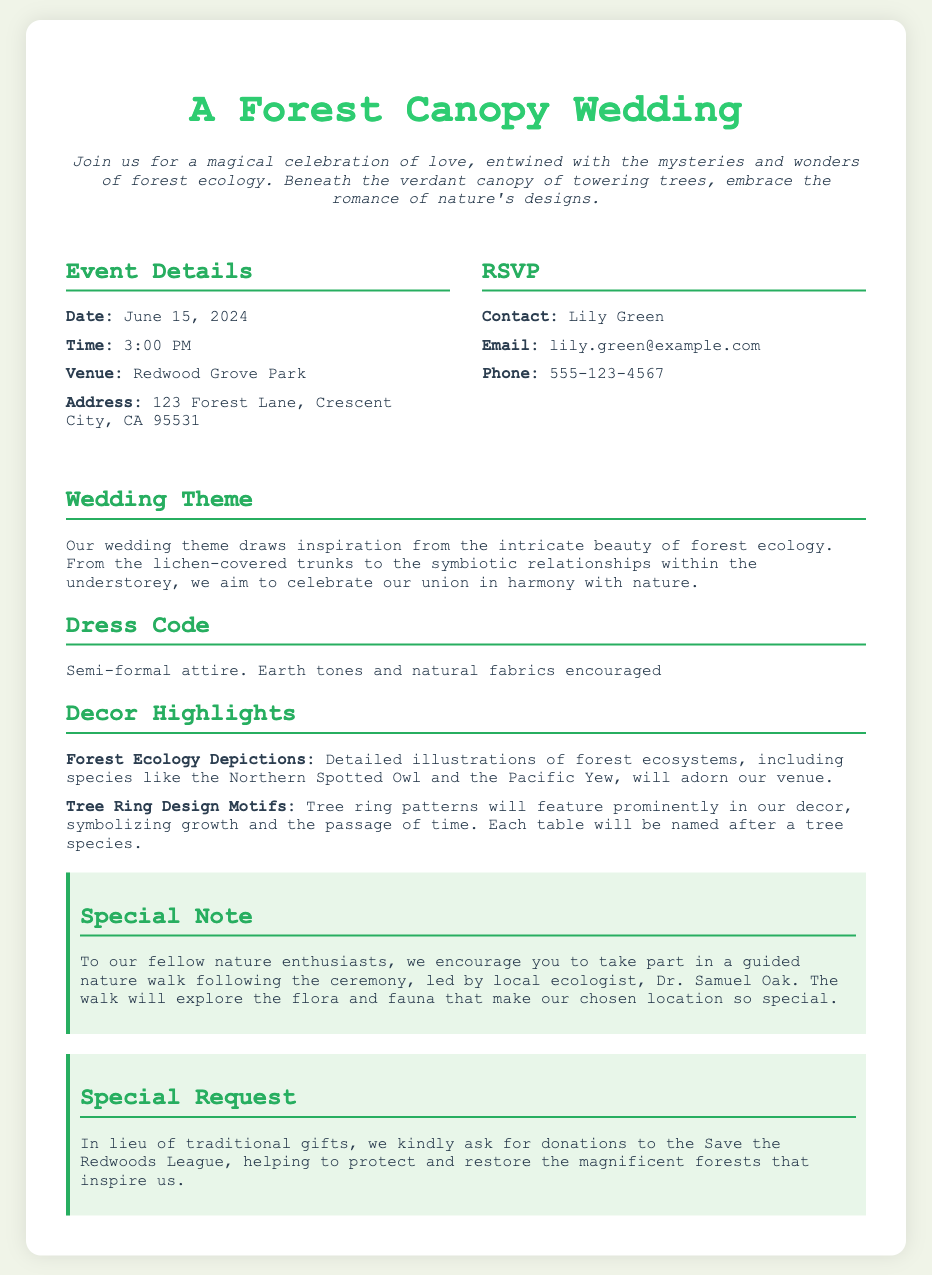What is the date of the wedding? The date of the wedding is specified in the event details section of the document.
Answer: June 15, 2024 What time does the ceremony start? The time of the ceremony is listed under event details and specifies the starting hour.
Answer: 3:00 PM Where is the wedding venue located? The venue information is provided in the details section, including the venue name and address.
Answer: Redwood Grove Park Who should be contacted for RSVP? The RSVP contact is mentioned along with their name in the RSVP section of the invitation.
Answer: Lily Green What dress code is suggested? The dress code is highlighted in the dress code section and outlines the style of attire requested.
Answer: Semi-formal attire What is the theme of the wedding? The wedding theme is described in a specific section, noting the inspiration behind it.
Answer: Forest ecology What unique feature will be included in the decor? Unique decor elements are mentioned, highlighting specific artistic representations.
Answer: Forest Ecology Depictions What special activity is planned after the ceremony? The document mentions a specific activity that guests can participate in following the ceremony.
Answer: Guided nature walk What is requested instead of traditional gifts? The special request section articulates what to consider in place of customary wedding gifts.
Answer: Donations to the Save the Redwoods League 